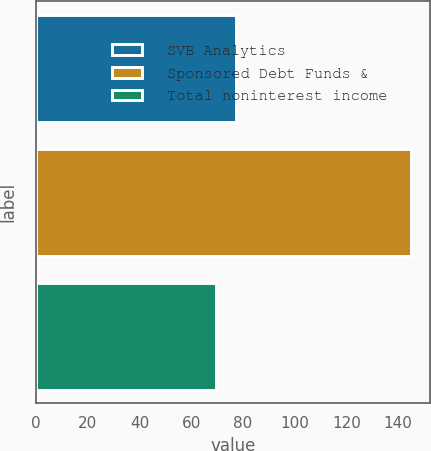Convert chart to OTSL. <chart><loc_0><loc_0><loc_500><loc_500><bar_chart><fcel>SVB Analytics<fcel>Sponsored Debt Funds &<fcel>Total noninterest income<nl><fcel>77.24<fcel>145.1<fcel>69.7<nl></chart> 